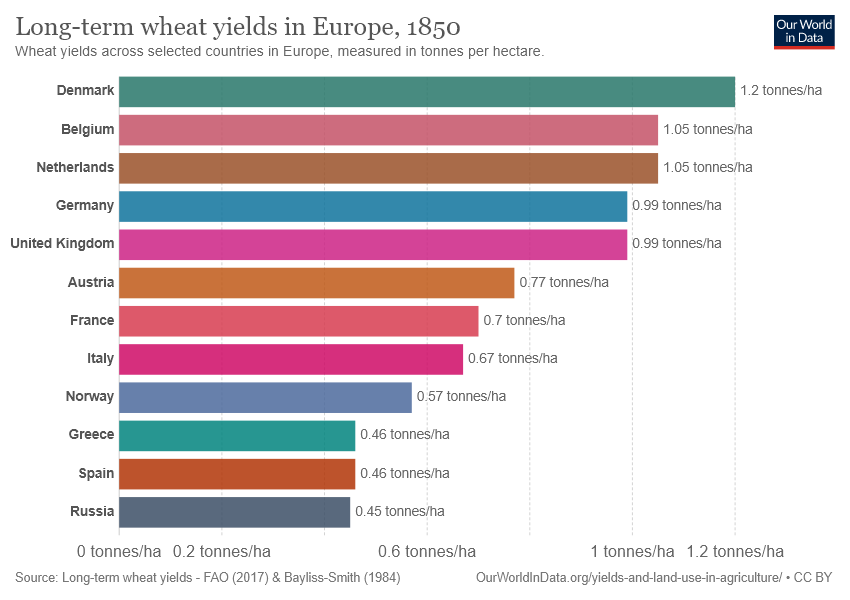Outline some significant characteristics in this image. The light blue color bar is denoted as Germany. The average of the bottom three countries is 0.456. 